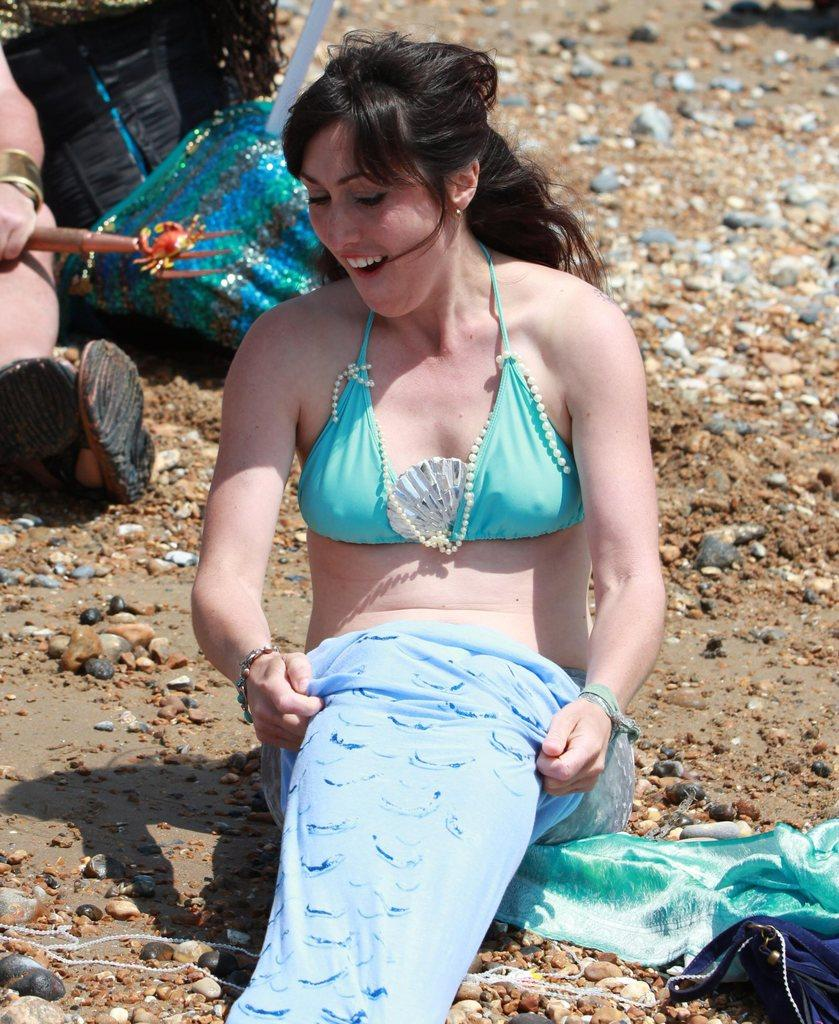Who is present in the image? There is a woman in the image. What is the woman wearing? The woman is wearing a blue dress. What is the woman's position in the image? The woman is sitting on the ground. What can be seen in the background of the image? There are bags in the background of the image. What type of natural elements are visible in the image? There are stones visible in the image. Can you tell me how many grapes the woman is holding in the image? There are no grapes present in the image. What type of help is the woman providing in the image? The image does not show the woman providing any help or assistance. 